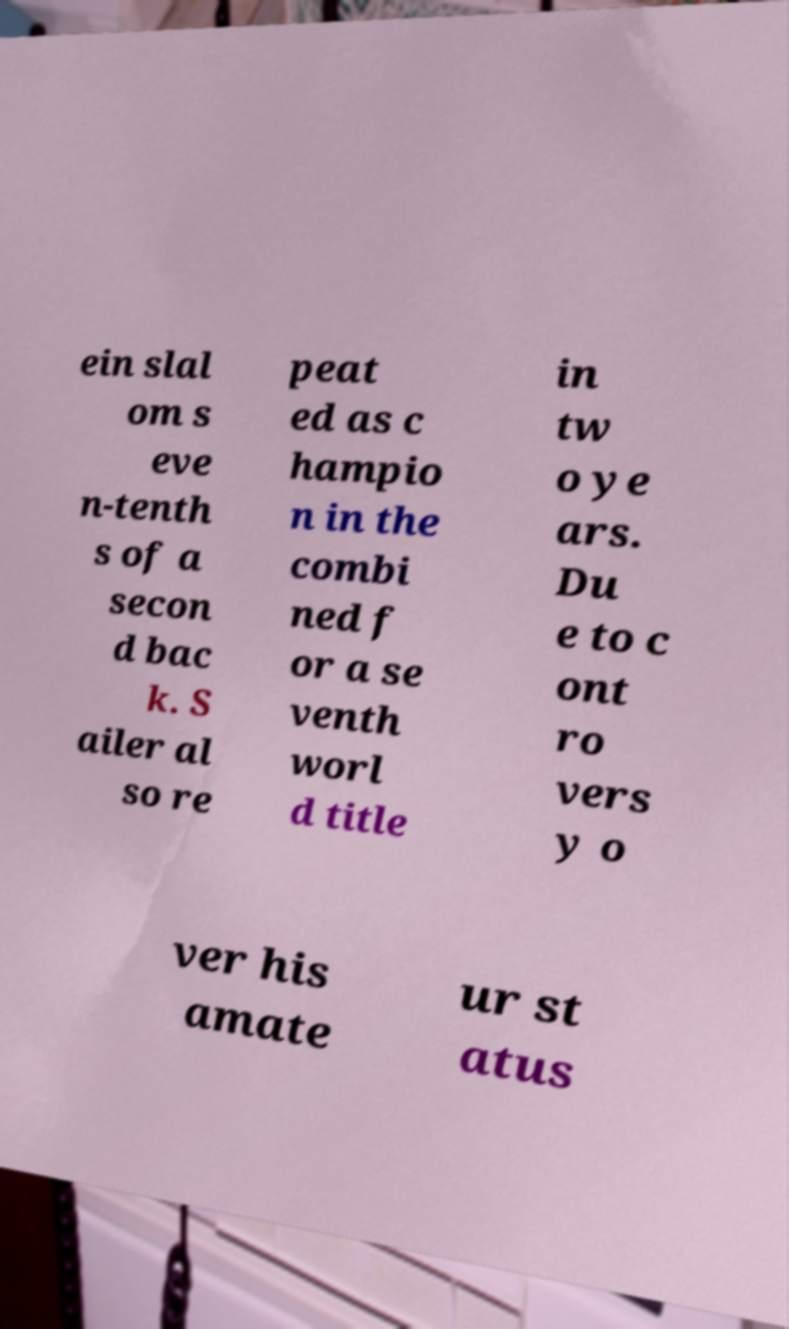Can you accurately transcribe the text from the provided image for me? ein slal om s eve n-tenth s of a secon d bac k. S ailer al so re peat ed as c hampio n in the combi ned f or a se venth worl d title in tw o ye ars. Du e to c ont ro vers y o ver his amate ur st atus 